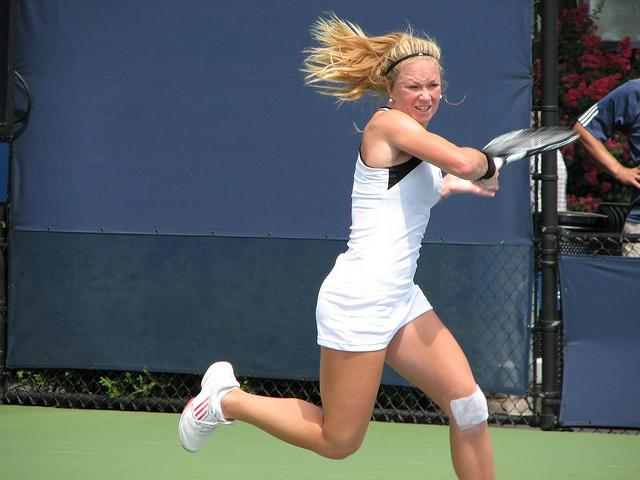What happened to this players left knee?

Choices:
A) break
B) sunburn
C) nothing
D) cut cut 